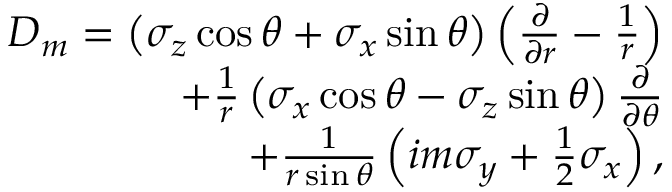<formula> <loc_0><loc_0><loc_500><loc_500>\begin{array} { r } { D _ { m } = \left ( \sigma _ { z } \cos \theta + \sigma _ { x } \sin \theta \right ) \left ( \frac { \partial } { \partial r } - \frac { 1 } { r } \right ) } \\ { + \frac { 1 } { r } \left ( \sigma _ { x } \cos \theta - \sigma _ { z } \sin \theta \right ) \frac { \partial } { \partial \theta } } \\ { + \frac { 1 } { r \sin \theta } \left ( i m \sigma _ { y } + \frac { 1 } { 2 } \sigma _ { x } \right ) , } \end{array}</formula> 